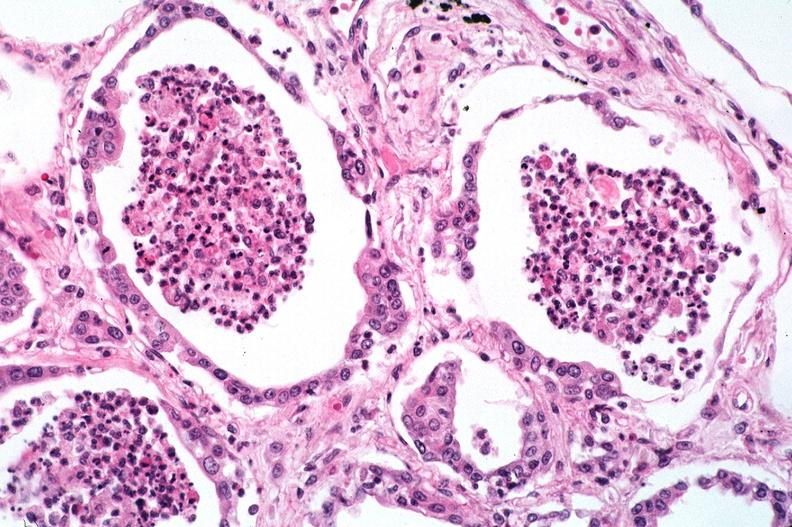where is this?
Answer the question using a single word or phrase. Lung 